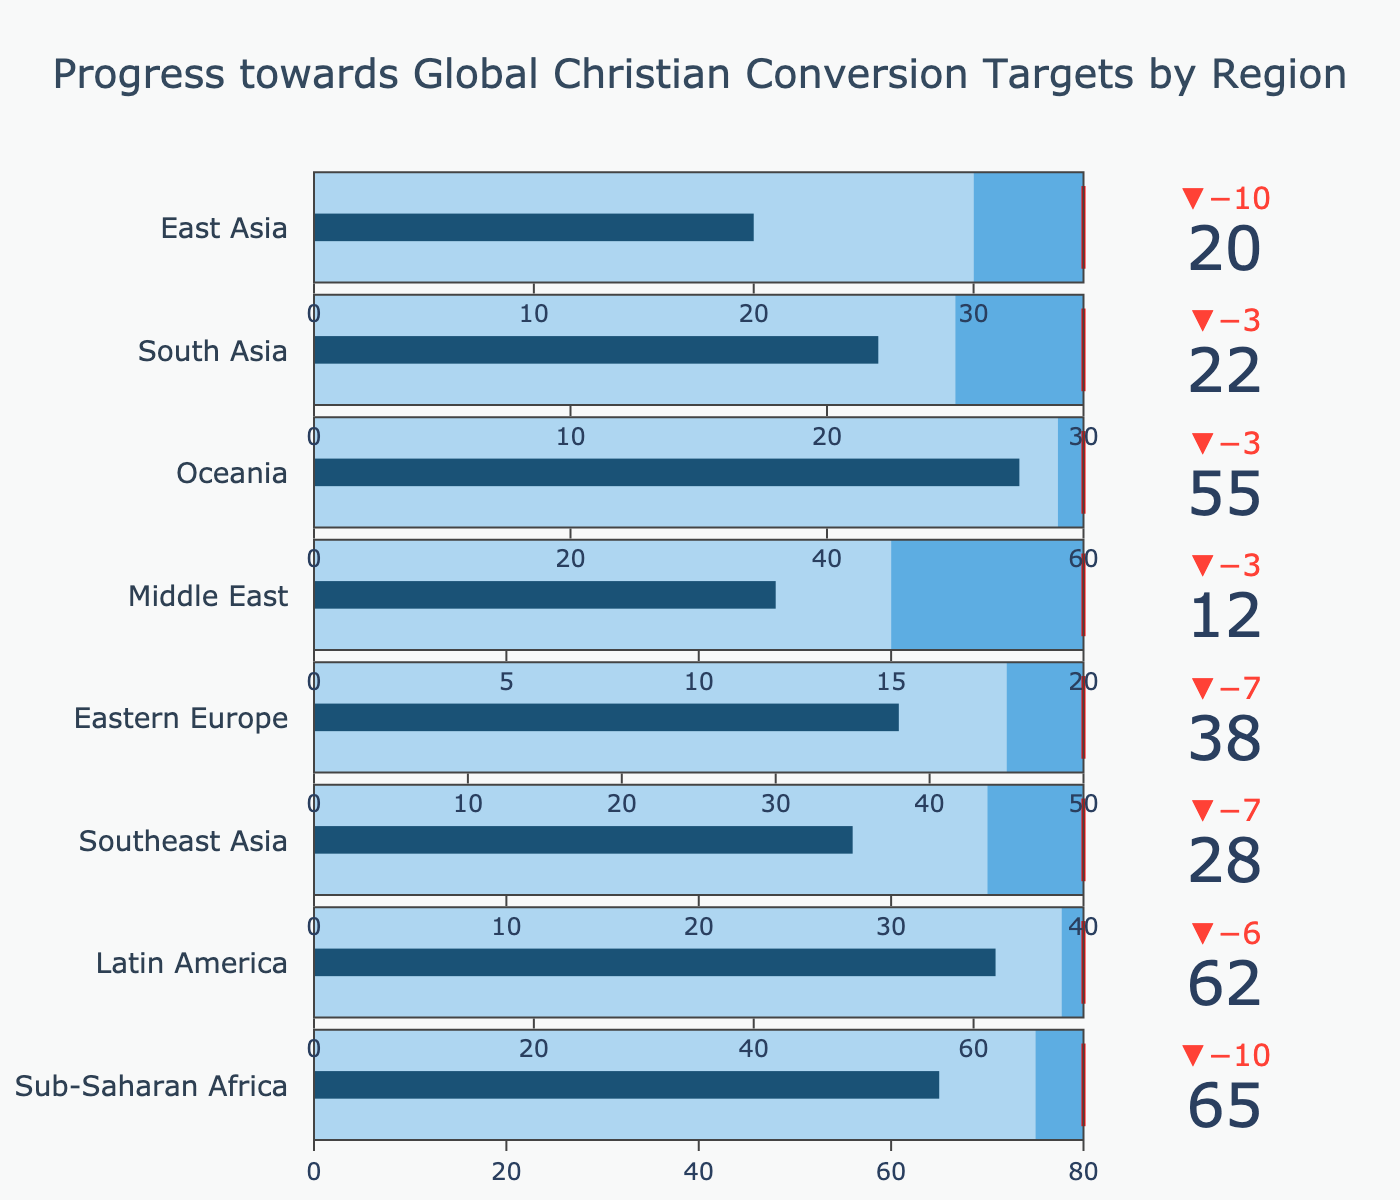What is the title of the figure? The title is written at the top center of the figure, it reads "Progress towards Global Christian Conversion Targets by Region".
Answer: Progress towards Global Christian Conversion Targets by Region Which region has the highest target for Christian conversion? By looking at the gauge thresholds, Sub-Saharan Africa has the highest target set at 80.
Answer: Sub-Saharan Africa How many regions have an actual value higher than their comparative value? By comparing the 'Actual' and 'Comparative' values for each region from the visual, Sub-Saharan Africa, Latin America, and Oceania have actual values higher than their comparative values.
Answer: 3 regions What is the difference between the target and actual value for South Asia? The target for South Asia is 30, and the actual value is 22. Subtracting these gives the difference: 30 - 22 = 8.
Answer: 8 Which region has the smallest delta between actual and comparative values? The delta can be observed from the bullet chart measures. Oceania has the smallest delta, where the actual value (55) is closer to the comparative value (58) with a difference of 3.
Answer: Oceania Does any region have an actual value that exceeds the target? Upon examining all regions, none of the actual values exceed their respective targets.
Answer: No How does the Middle East's progress compare to its target? The Middle East has a target of 20 and an actual value of 12, showing that it is significantly behind its target.
Answer: Behind Which region shows the largest underperformance relative to the target? Comparing the differences, Southeast Asia has an actual value of 28 compared to its target of 40, showing the largest deficit of 12.
Answer: Southeast Asia What can be inferred about Latin America's progress towards the target compared to the comparative value? Latin America has an actual value (62) that is higher than the comparative value (68), indicating it has made progress close to but slightly below its target of 70.
Answer: Near comparative but below target For Eastern Europe, what is the sum of the actual, comparative, and target values? Adding the values: Actual (38) + Comparative (45) + Target (50) = 133.
Answer: 133 